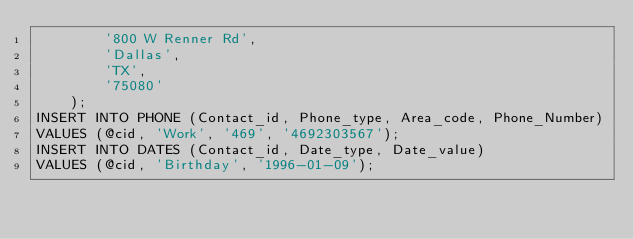Convert code to text. <code><loc_0><loc_0><loc_500><loc_500><_SQL_>        '800 W Renner Rd',
        'Dallas',
        'TX',
        '75080'
    );
INSERT INTO PHONE (Contact_id, Phone_type, Area_code, Phone_Number)
VALUES (@cid, 'Work', '469', '4692303567');
INSERT INTO DATES (Contact_id, Date_type, Date_value)
VALUES (@cid, 'Birthday', '1996-01-09');</code> 